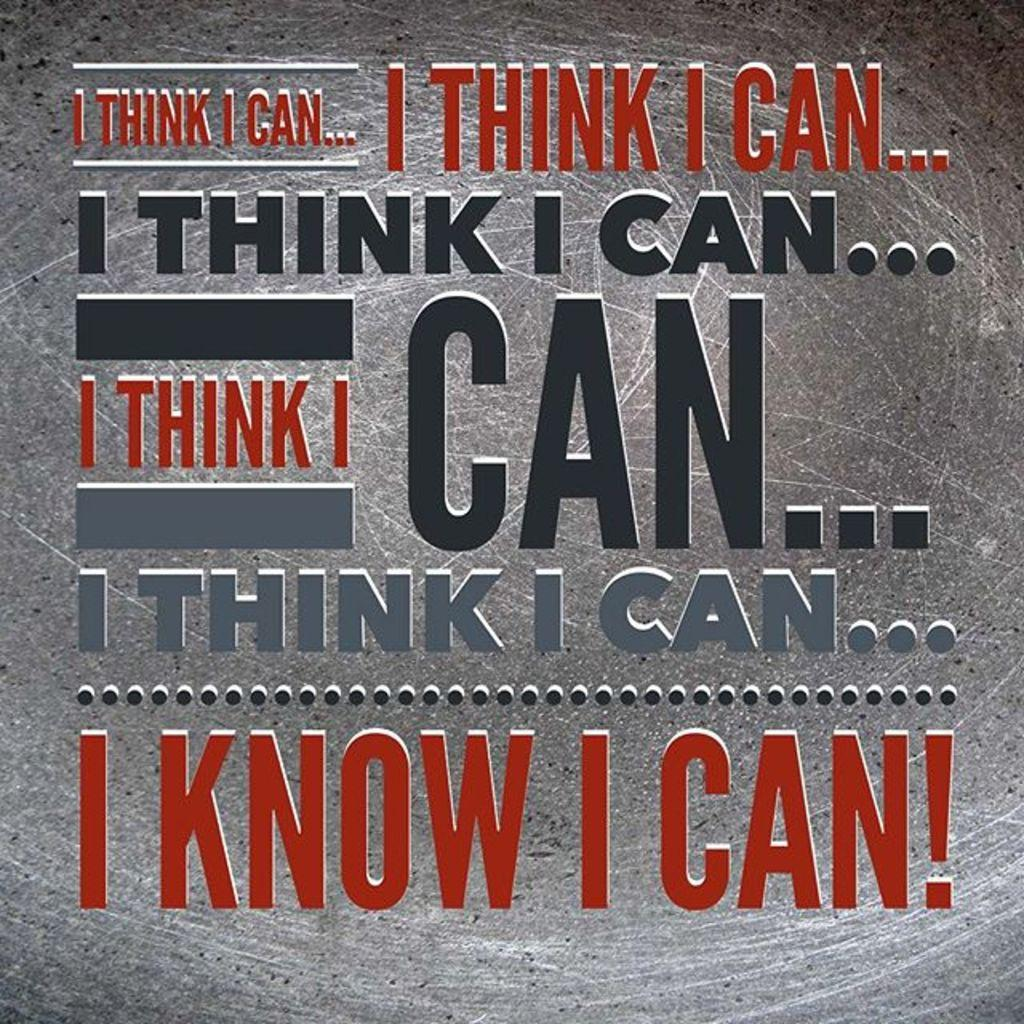<image>
Summarize the visual content of the image. A motivational quote that state, "I know I can" is written on a gray background. 